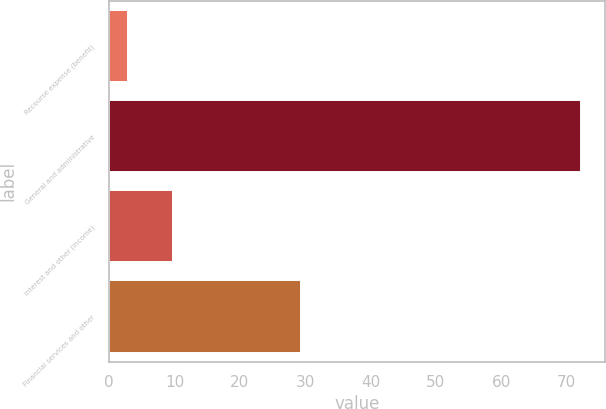Convert chart to OTSL. <chart><loc_0><loc_0><loc_500><loc_500><bar_chart><fcel>Recourse expense (benefit)<fcel>General and administrative<fcel>Interest and other (income)<fcel>Financial services and other<nl><fcel>2.8<fcel>72.3<fcel>9.75<fcel>29.3<nl></chart> 